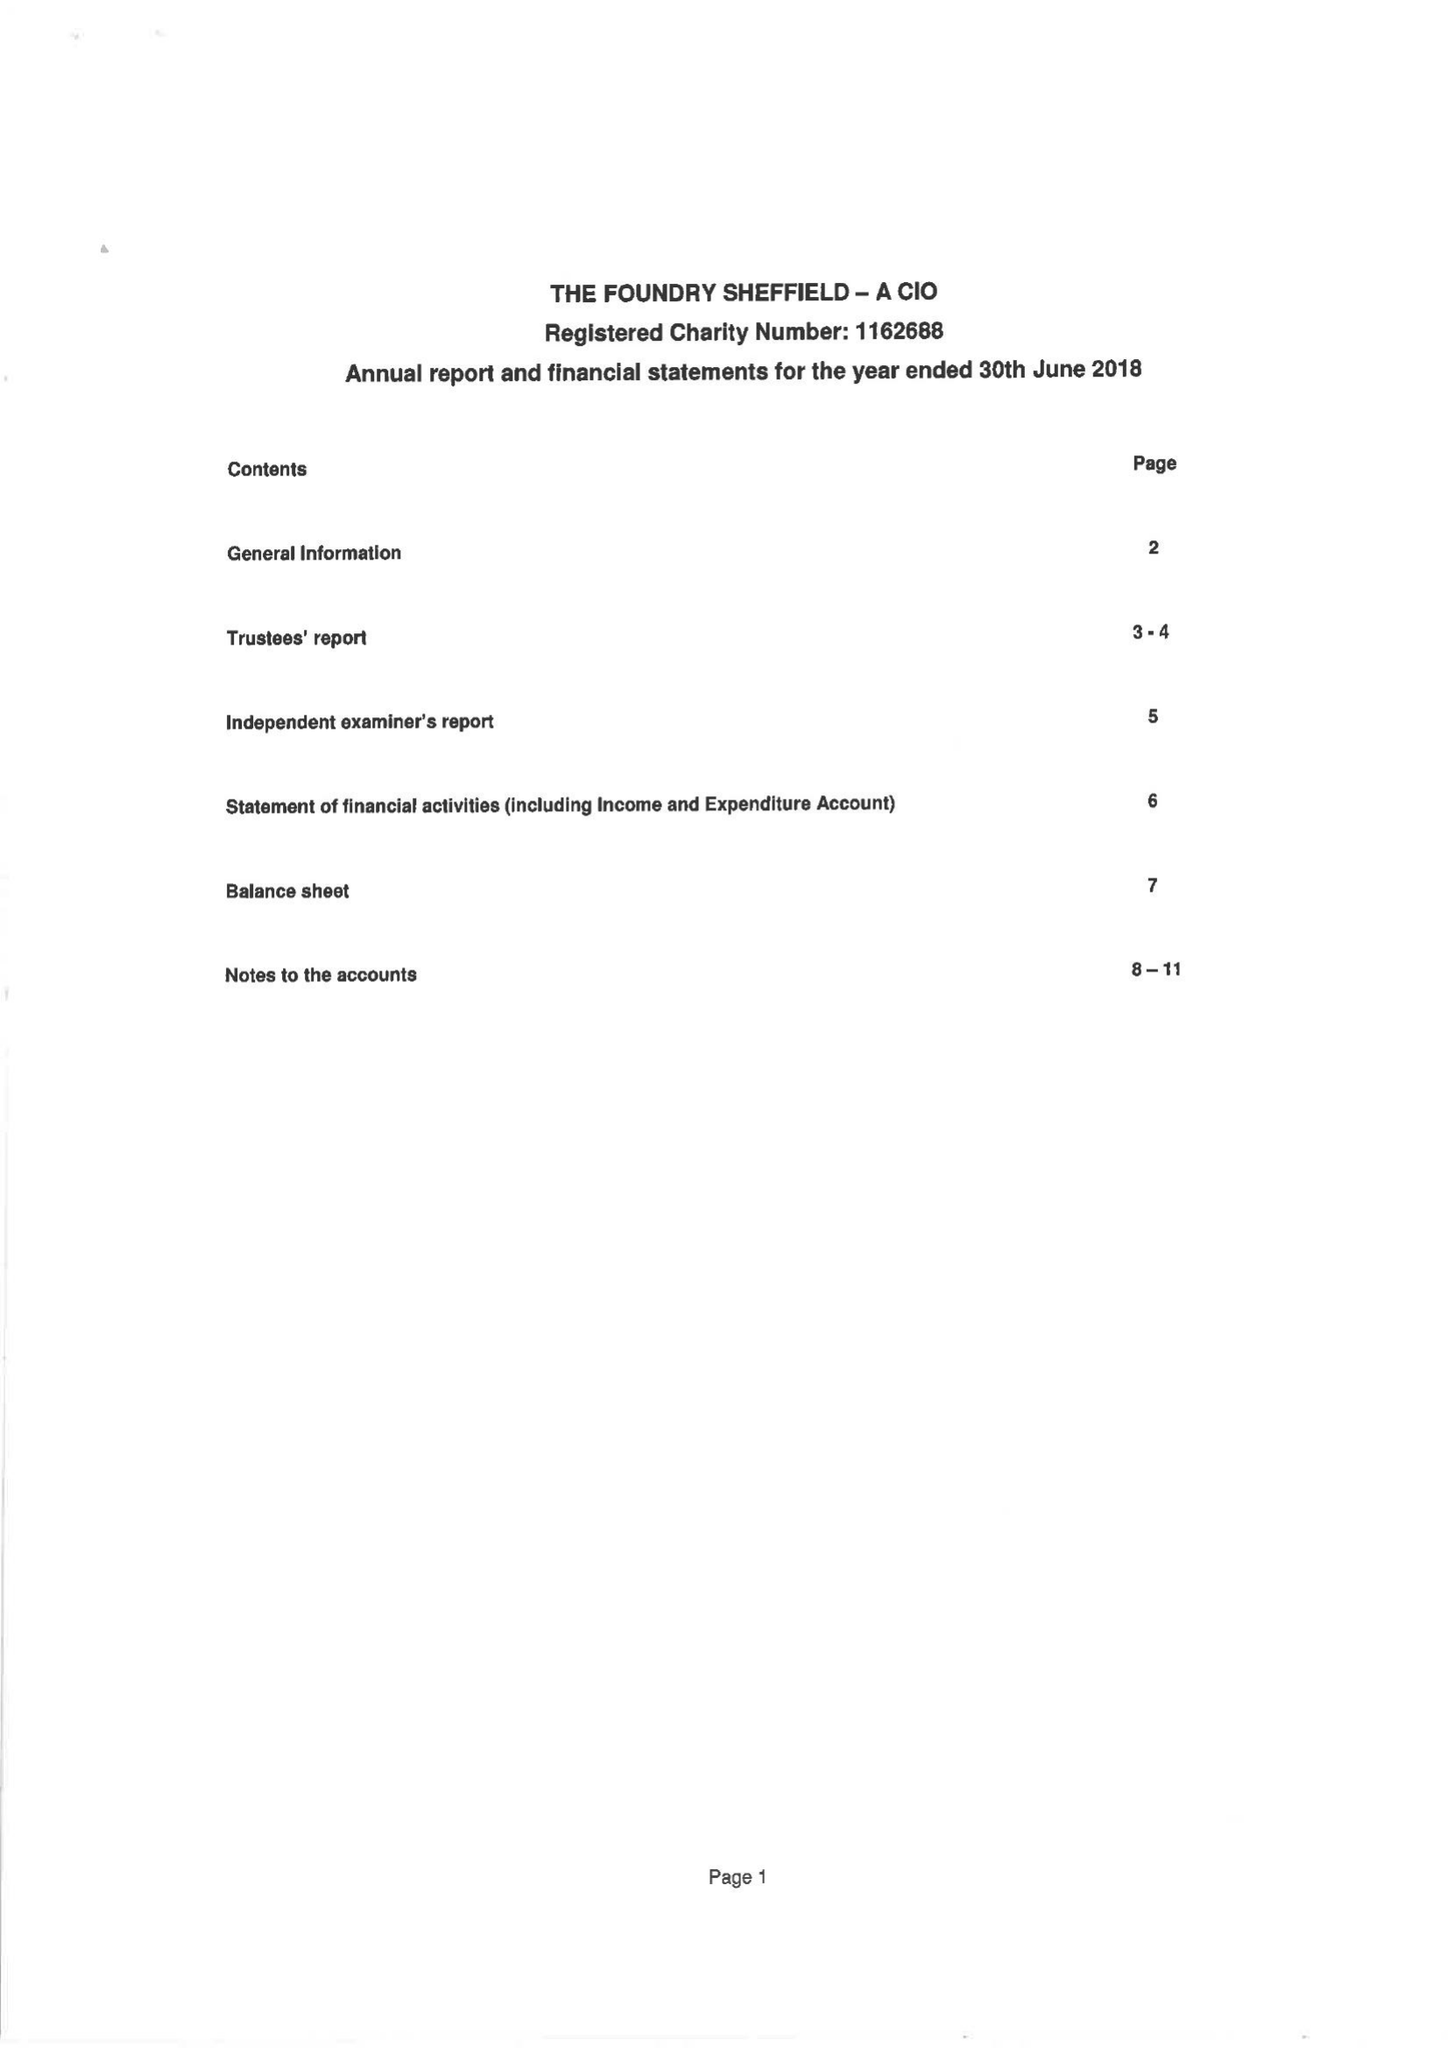What is the value for the income_annually_in_british_pounds?
Answer the question using a single word or phrase. 221754.00 